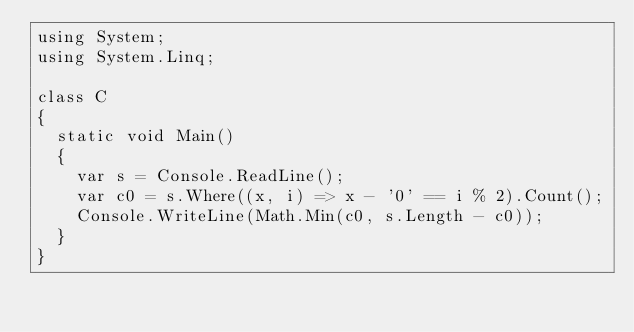<code> <loc_0><loc_0><loc_500><loc_500><_C#_>using System;
using System.Linq;

class C
{
	static void Main()
	{
		var s = Console.ReadLine();
		var c0 = s.Where((x, i) => x - '0' == i % 2).Count();
		Console.WriteLine(Math.Min(c0, s.Length - c0));
	}
}
</code> 